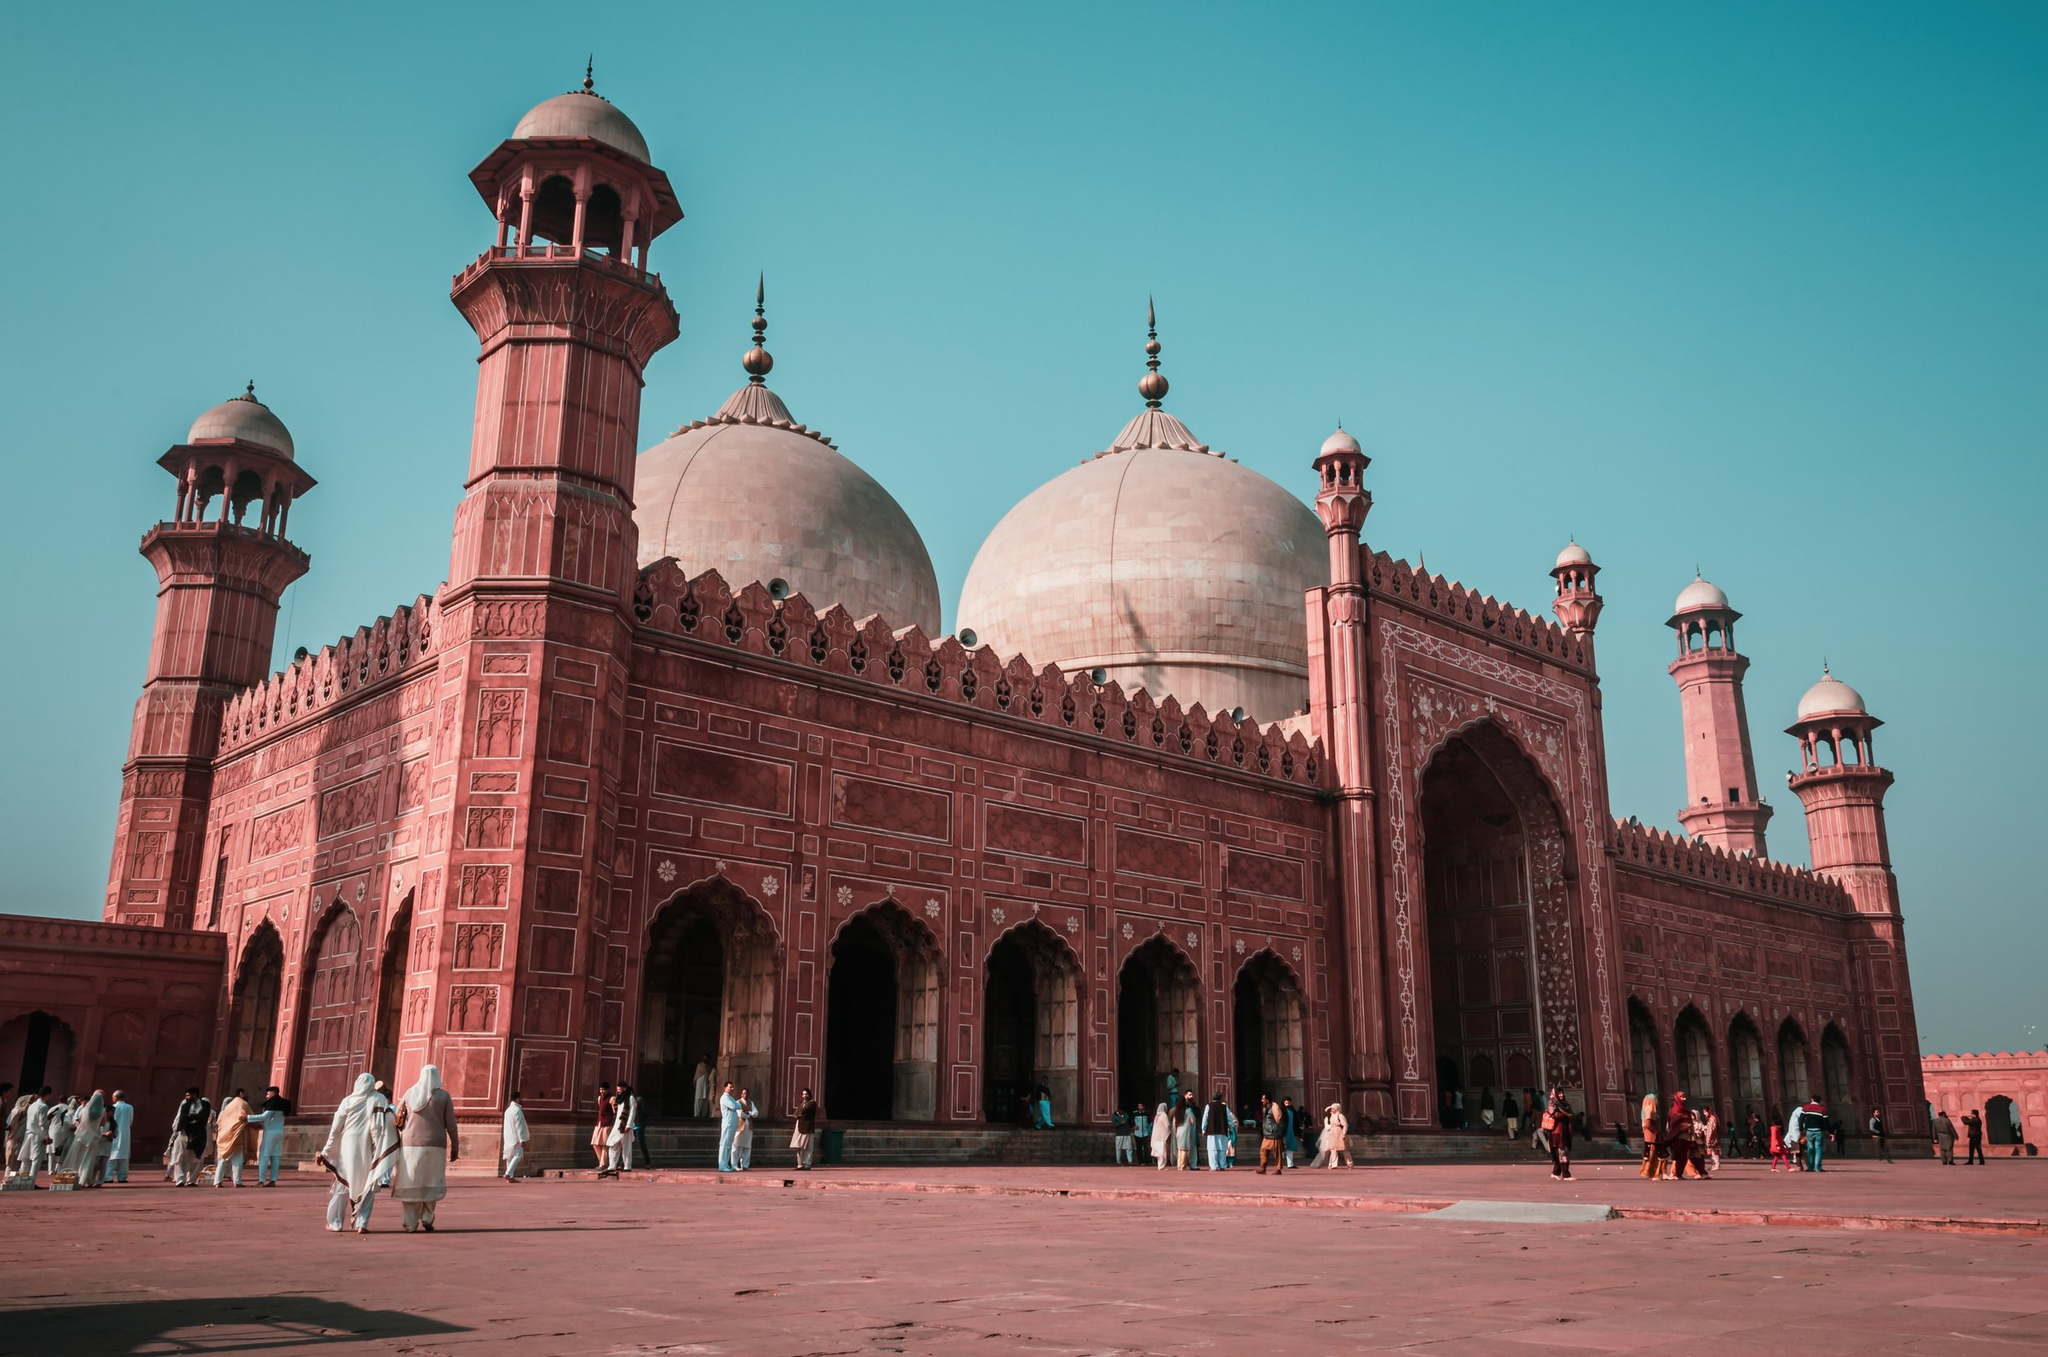What do you think is going on in this snapshot? This snapshot showcases the majestic Badshahi Mosque, an iconic symbol of Mughal architecture located in Lahore, Pakistan. The red sandstone walls and white marble domes gleam under the sunlight, reflecting the mosque's grandeur. The courtyard teems with visitors, indicating its status as both a place of worship and a historical site attracting tourists from all over. The Badshahi Mosque is not only a religious center but also a monument steeped in history, dating back to 1673, serving as a testament to the city's rich cultural and religious heritage. 